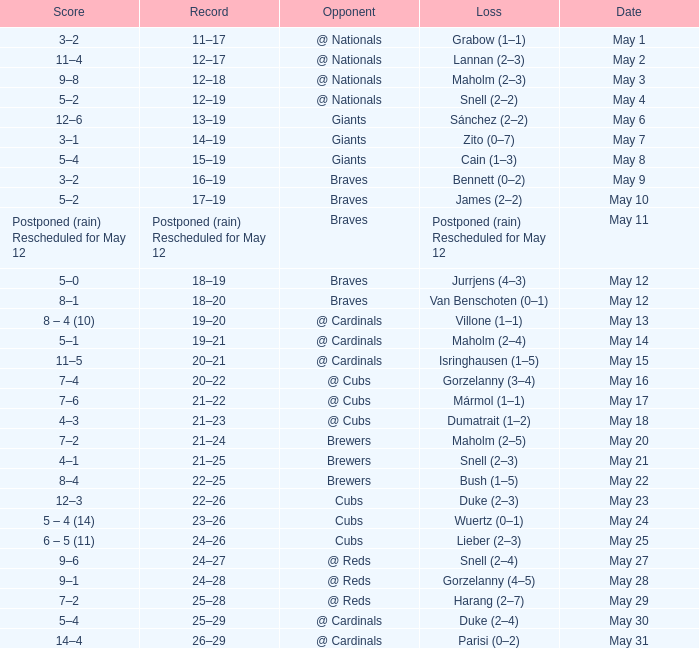Help me parse the entirety of this table. {'header': ['Score', 'Record', 'Opponent', 'Loss', 'Date'], 'rows': [['3–2', '11–17', '@ Nationals', 'Grabow (1–1)', 'May 1'], ['11–4', '12–17', '@ Nationals', 'Lannan (2–3)', 'May 2'], ['9–8', '12–18', '@ Nationals', 'Maholm (2–3)', 'May 3'], ['5–2', '12–19', '@ Nationals', 'Snell (2–2)', 'May 4'], ['12–6', '13–19', 'Giants', 'Sánchez (2–2)', 'May 6'], ['3–1', '14–19', 'Giants', 'Zito (0–7)', 'May 7'], ['5–4', '15–19', 'Giants', 'Cain (1–3)', 'May 8'], ['3–2', '16–19', 'Braves', 'Bennett (0–2)', 'May 9'], ['5–2', '17–19', 'Braves', 'James (2–2)', 'May 10'], ['Postponed (rain) Rescheduled for May 12', 'Postponed (rain) Rescheduled for May 12', 'Braves', 'Postponed (rain) Rescheduled for May 12', 'May 11'], ['5–0', '18–19', 'Braves', 'Jurrjens (4–3)', 'May 12'], ['8–1', '18–20', 'Braves', 'Van Benschoten (0–1)', 'May 12'], ['8 – 4 (10)', '19–20', '@ Cardinals', 'Villone (1–1)', 'May 13'], ['5–1', '19–21', '@ Cardinals', 'Maholm (2–4)', 'May 14'], ['11–5', '20–21', '@ Cardinals', 'Isringhausen (1–5)', 'May 15'], ['7–4', '20–22', '@ Cubs', 'Gorzelanny (3–4)', 'May 16'], ['7–6', '21–22', '@ Cubs', 'Mármol (1–1)', 'May 17'], ['4–3', '21–23', '@ Cubs', 'Dumatrait (1–2)', 'May 18'], ['7–2', '21–24', 'Brewers', 'Maholm (2–5)', 'May 20'], ['4–1', '21–25', 'Brewers', 'Snell (2–3)', 'May 21'], ['8–4', '22–25', 'Brewers', 'Bush (1–5)', 'May 22'], ['12–3', '22–26', 'Cubs', 'Duke (2–3)', 'May 23'], ['5 – 4 (14)', '23–26', 'Cubs', 'Wuertz (0–1)', 'May 24'], ['6 – 5 (11)', '24–26', 'Cubs', 'Lieber (2–3)', 'May 25'], ['9–6', '24–27', '@ Reds', 'Snell (2–4)', 'May 27'], ['9–1', '24–28', '@ Reds', 'Gorzelanny (4–5)', 'May 28'], ['7–2', '25–28', '@ Reds', 'Harang (2–7)', 'May 29'], ['5–4', '25–29', '@ Cardinals', 'Duke (2–4)', 'May 30'], ['14–4', '26–29', '@ Cardinals', 'Parisi (0–2)', 'May 31']]} What was the score of the game with a loss of Maholm (2–4)? 5–1. 